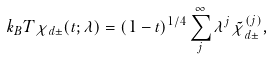<formula> <loc_0><loc_0><loc_500><loc_500>k _ { B } T \chi _ { d \pm } ( t ; \lambda ) = ( 1 - t ) ^ { 1 / 4 } \sum _ { j } ^ { \infty } \lambda ^ { j } { \tilde { \chi } } ^ { ( j ) } _ { d \pm } ,</formula> 